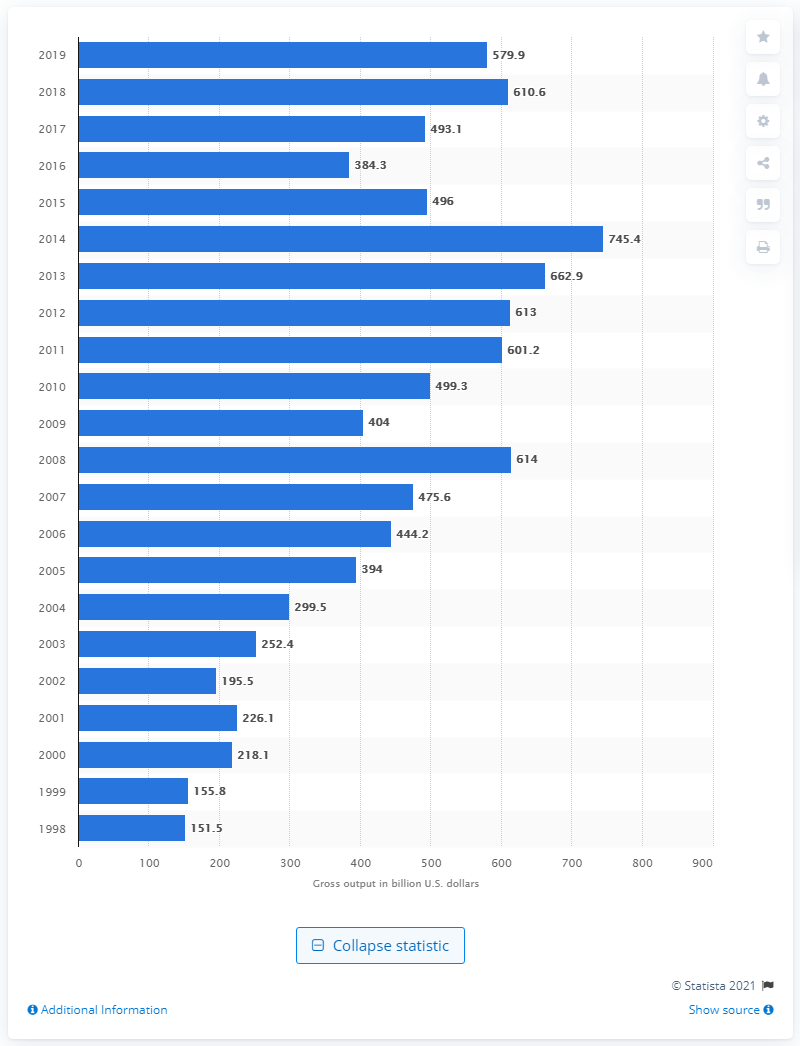List a handful of essential elements in this visual. The gross output of the mining industry in 2019 was 579.9 billion U.S. dollars. 